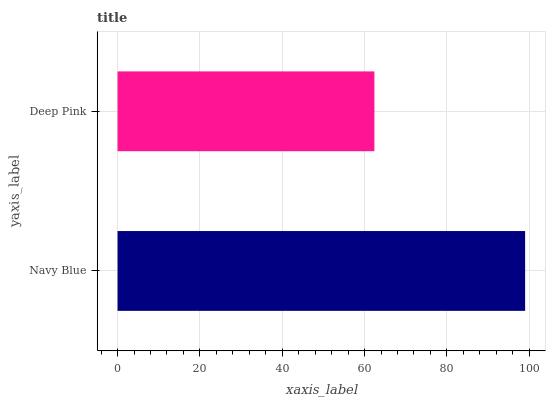Is Deep Pink the minimum?
Answer yes or no. Yes. Is Navy Blue the maximum?
Answer yes or no. Yes. Is Deep Pink the maximum?
Answer yes or no. No. Is Navy Blue greater than Deep Pink?
Answer yes or no. Yes. Is Deep Pink less than Navy Blue?
Answer yes or no. Yes. Is Deep Pink greater than Navy Blue?
Answer yes or no. No. Is Navy Blue less than Deep Pink?
Answer yes or no. No. Is Navy Blue the high median?
Answer yes or no. Yes. Is Deep Pink the low median?
Answer yes or no. Yes. Is Deep Pink the high median?
Answer yes or no. No. Is Navy Blue the low median?
Answer yes or no. No. 